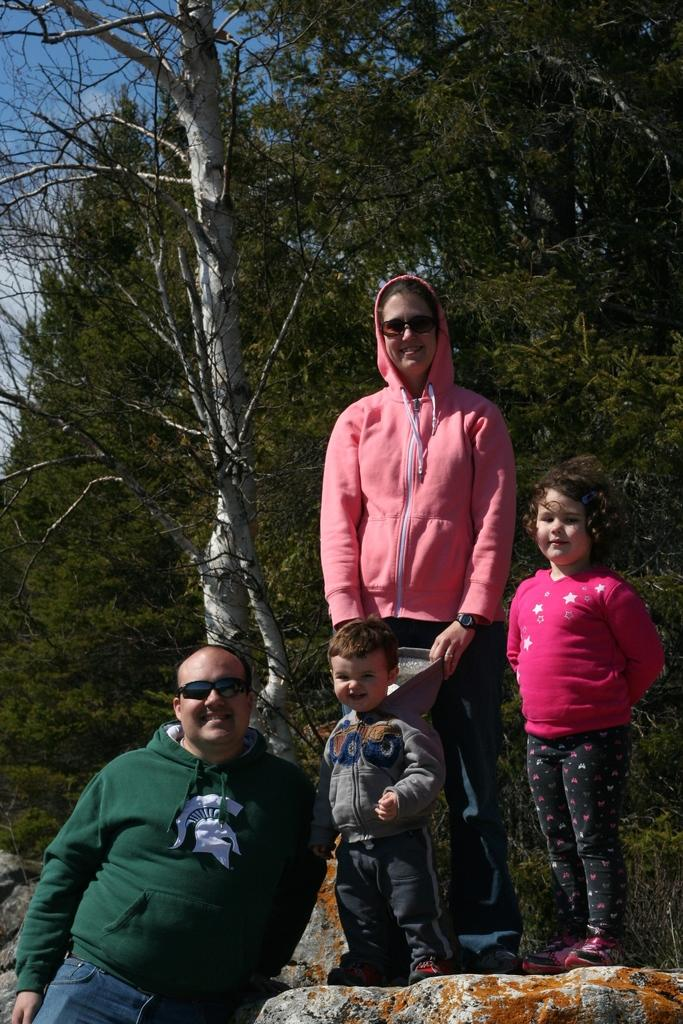How many people are present in the image? There are two persons standing in the image. What are the persons wearing? The persons are wearing goggles. How many children are present in the image? There are two children standing in the image. Where are the children standing? The children are standing on a rock. What can be seen in the background of the image? There are trees and the sky visible in the background of the image. What type of farm animals can be seen grazing on the edge of the image? There are no farm animals or edges present in the image; it features two persons, two children, trees, and the sky in the background. 